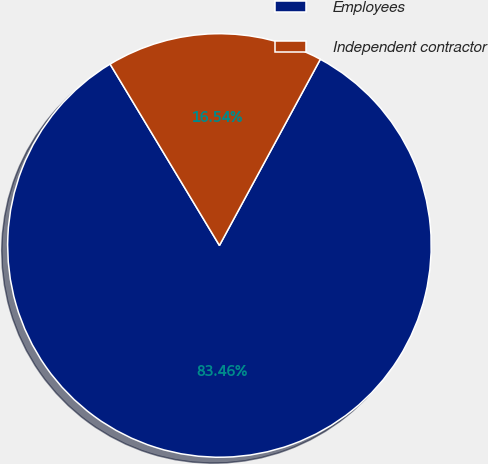Convert chart. <chart><loc_0><loc_0><loc_500><loc_500><pie_chart><fcel>Employees<fcel>Independent contractor<nl><fcel>83.46%<fcel>16.54%<nl></chart> 